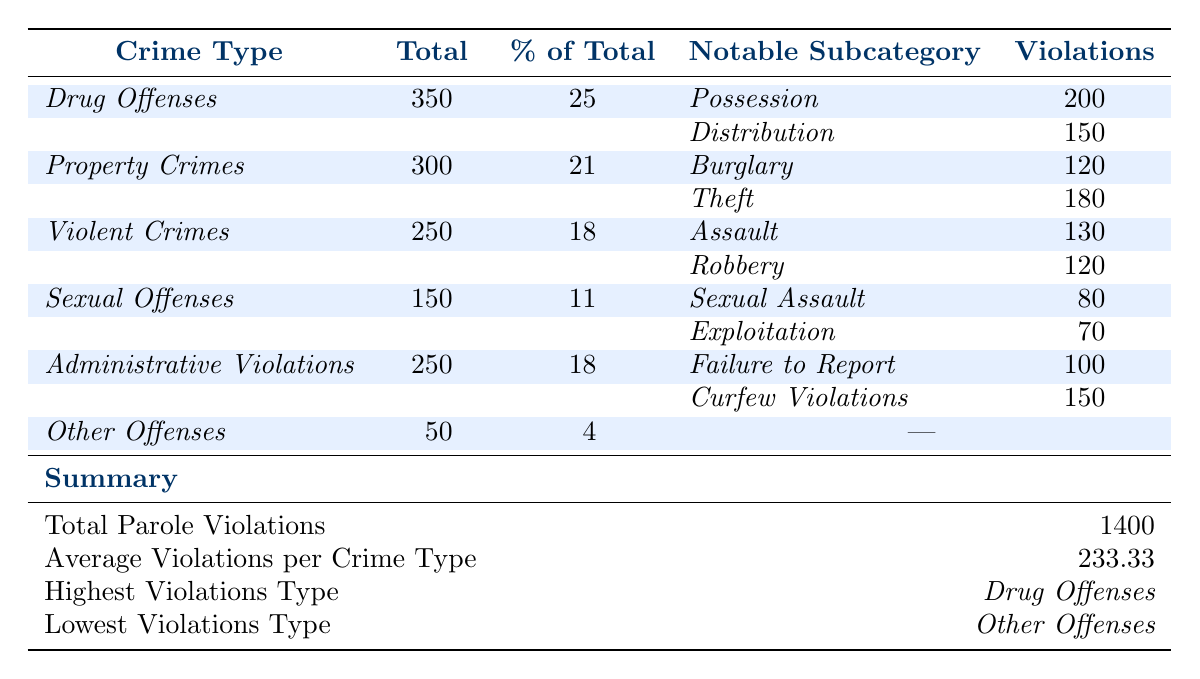What is the total number of parole violations for *Drug Offenses*? The table indicates that the total number of violations for *Drug Offenses* is listed directly under that crime type as 350.
Answer: 350 What percentage of total parole violations does *Property Crimes* represent? The percentage is shown in the column beside *Property Crimes*; it reads 21.
Answer: 21% What is the notable subcategory with the highest number of violations under *Violent Crimes*? Within *Violent Crimes*, the notable subcategories are *Assault* with 130 violations and *Robbery* with 120; *Assault* has the highest violations of 130.
Answer: *Assault* What is the average number of violations across all crime types? The summary section states the average number of violations per crime type is calculated as 233.33, based on a total of 1400 violations divided by 6 types.
Answer: 233.33 Which crime type has the lowest number of violations, and what is that number? The summary indicates that the lowest number of violations corresponds to *Other Offenses*, with a total of 50 violations.
Answer: *Other Offenses*, 50 If the total number of parole violations is 1400, what is the combined total of violations for *Sexual Offenses* and *Other Offenses*? The total for *Sexual Offenses* is 150 and for *Other Offenses* is 50; adding these gives 150 + 50 = 200.
Answer: 200 Is the percentage of violations for *Drug Offenses* higher than 25%? The table clearly states that the percentage for *Drug Offenses* is 25%, which is not greater than 25%.
Answer: No What crime type contributes to a higher total of violations: *Administrative Violations* or *Violent Crimes*? The total for *Administrative Violations* is 250 and for *Violent Crimes* is 250 as well; they are equal.
Answer: Equal How many violations are attributed to *Curfew Violations* under *Administrative Violations*? The table shows that *Curfew Violations* have a total of 150 violations under the *Administrative Violations* category.
Answer: 150 What is the combined total of violations for the notable subcategories under *Drug Offenses*? The notable subcategories listed are *Possession* (200) and *Distribution* (150); thus, the total is 200 + 150 = 350.
Answer: 350 